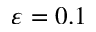<formula> <loc_0><loc_0><loc_500><loc_500>\varepsilon = 0 . 1</formula> 